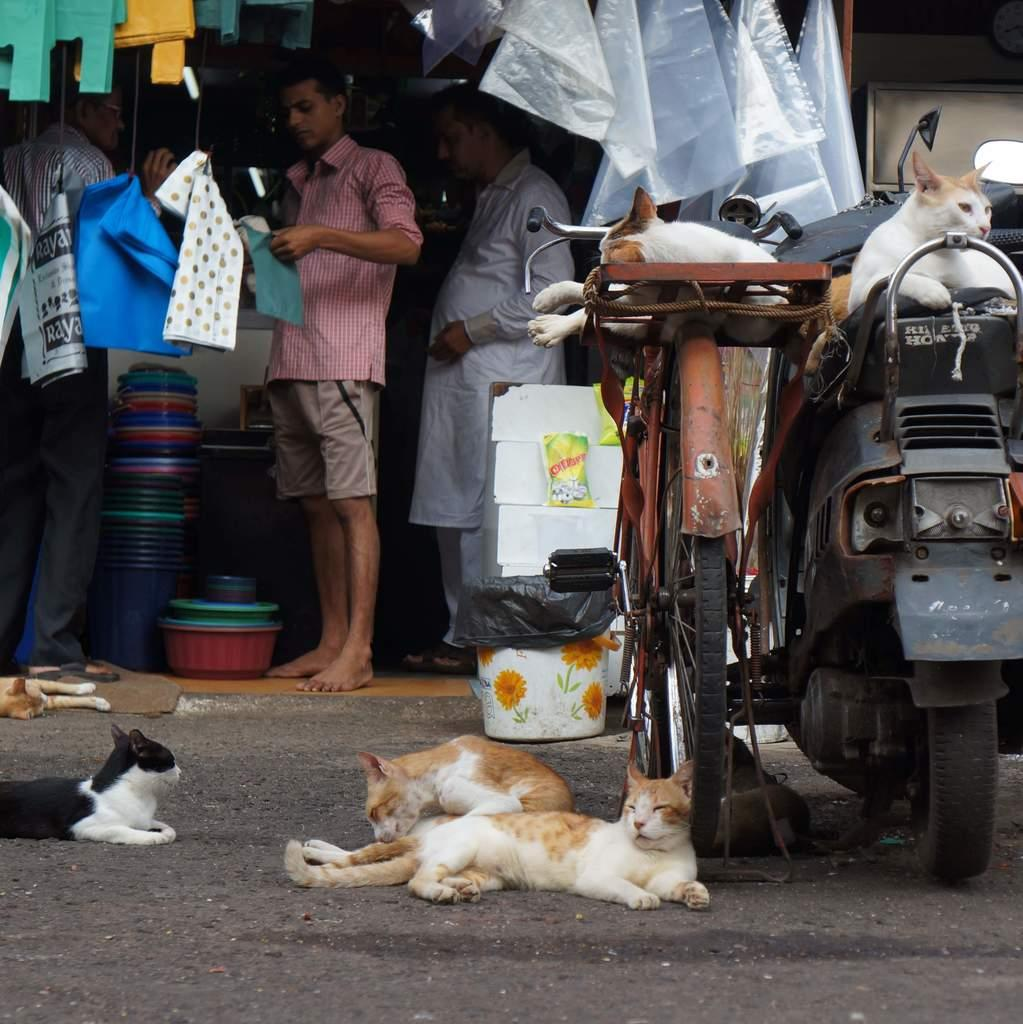What can be seen in the image in terms of human presence? There are people standing in the image. What type of material is present in the image? There are polythene covers in the image. What mode of transportation is visible in the image? There is a bicycle and a vehicle in the image. Are there any animals present in the image? Yes, there are cats in the image. What is the setting of the image? There is a road at the bottom of the image. What type of record is being played in the image? There is no record player or music playing in the image. Can you compare the prices of the items in the market shown in the image? There is no market present in the image, so it is not possible to compare the prices of items. 